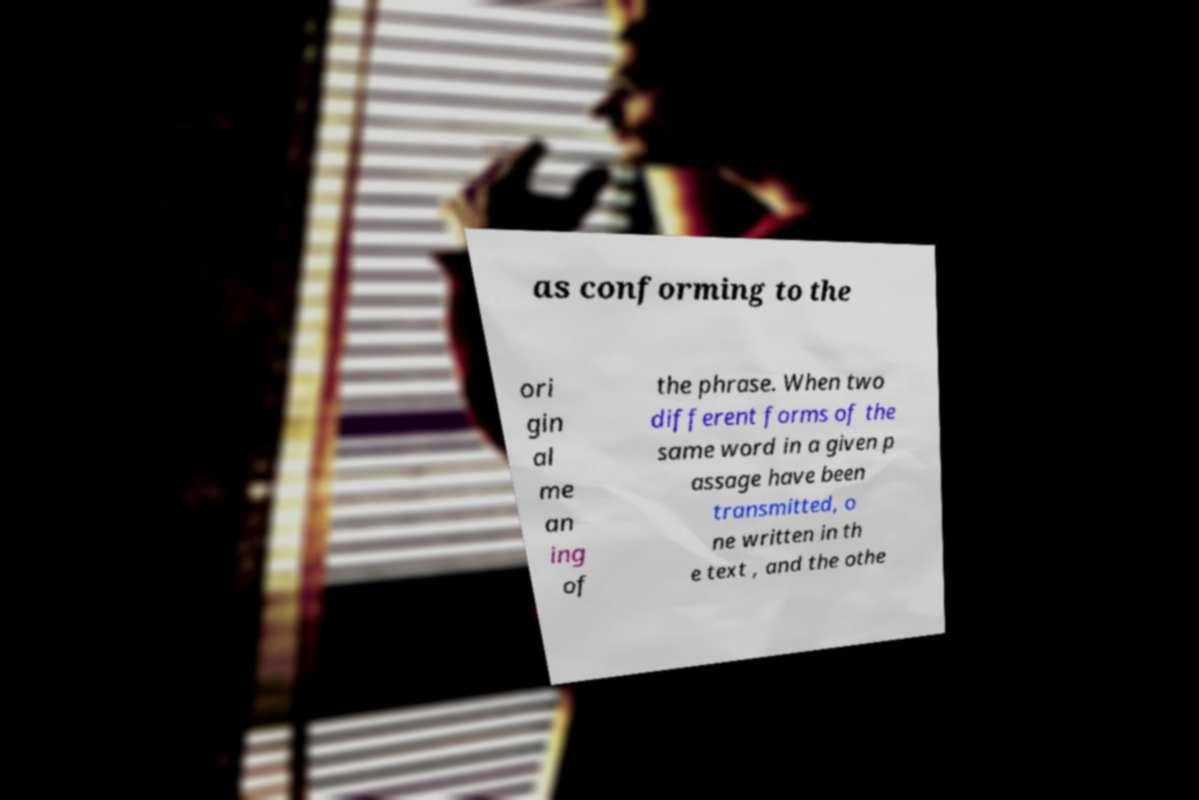Please read and relay the text visible in this image. What does it say? as conforming to the ori gin al me an ing of the phrase. When two different forms of the same word in a given p assage have been transmitted, o ne written in th e text , and the othe 